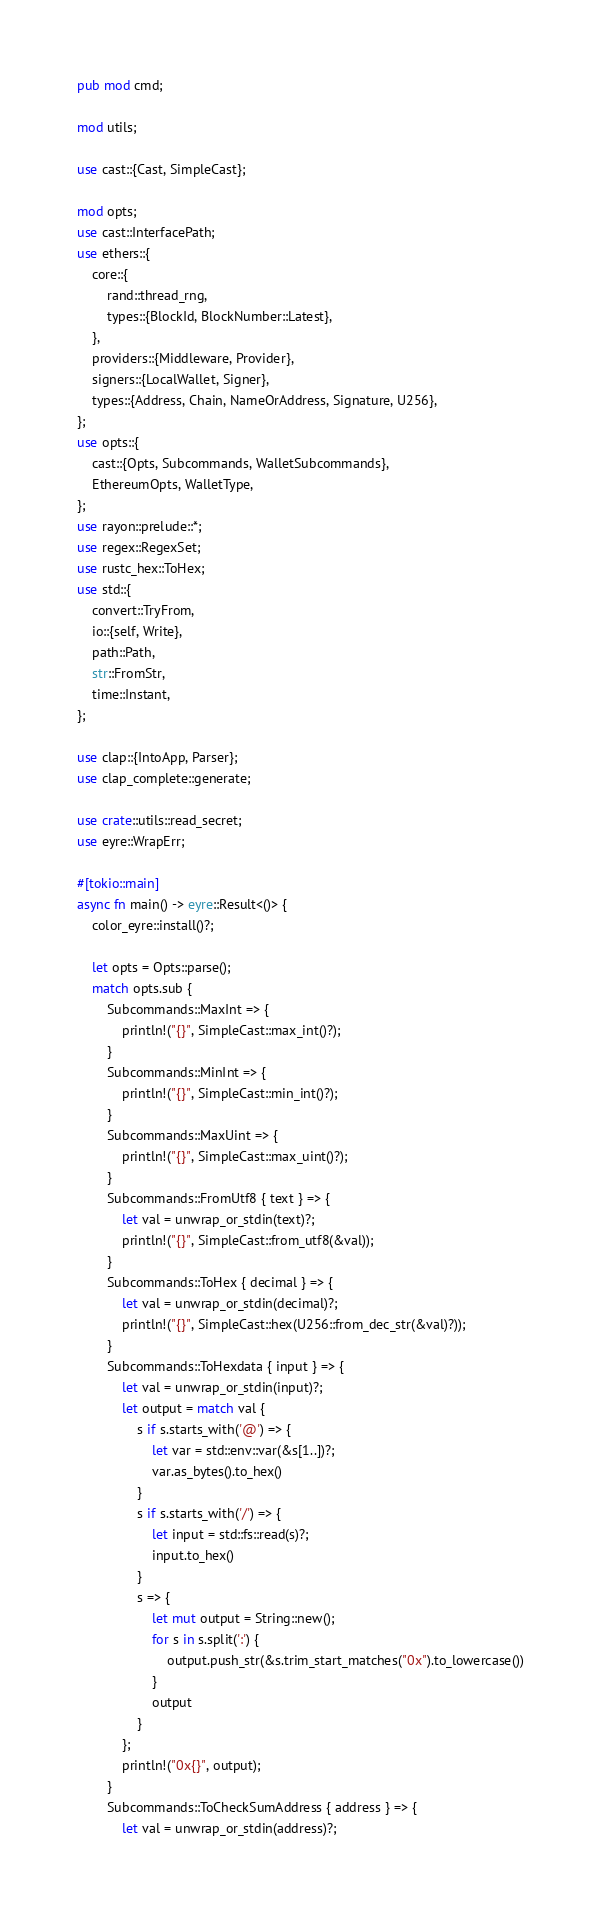<code> <loc_0><loc_0><loc_500><loc_500><_Rust_>pub mod cmd;

mod utils;

use cast::{Cast, SimpleCast};

mod opts;
use cast::InterfacePath;
use ethers::{
    core::{
        rand::thread_rng,
        types::{BlockId, BlockNumber::Latest},
    },
    providers::{Middleware, Provider},
    signers::{LocalWallet, Signer},
    types::{Address, Chain, NameOrAddress, Signature, U256},
};
use opts::{
    cast::{Opts, Subcommands, WalletSubcommands},
    EthereumOpts, WalletType,
};
use rayon::prelude::*;
use regex::RegexSet;
use rustc_hex::ToHex;
use std::{
    convert::TryFrom,
    io::{self, Write},
    path::Path,
    str::FromStr,
    time::Instant,
};

use clap::{IntoApp, Parser};
use clap_complete::generate;

use crate::utils::read_secret;
use eyre::WrapErr;

#[tokio::main]
async fn main() -> eyre::Result<()> {
    color_eyre::install()?;

    let opts = Opts::parse();
    match opts.sub {
        Subcommands::MaxInt => {
            println!("{}", SimpleCast::max_int()?);
        }
        Subcommands::MinInt => {
            println!("{}", SimpleCast::min_int()?);
        }
        Subcommands::MaxUint => {
            println!("{}", SimpleCast::max_uint()?);
        }
        Subcommands::FromUtf8 { text } => {
            let val = unwrap_or_stdin(text)?;
            println!("{}", SimpleCast::from_utf8(&val));
        }
        Subcommands::ToHex { decimal } => {
            let val = unwrap_or_stdin(decimal)?;
            println!("{}", SimpleCast::hex(U256::from_dec_str(&val)?));
        }
        Subcommands::ToHexdata { input } => {
            let val = unwrap_or_stdin(input)?;
            let output = match val {
                s if s.starts_with('@') => {
                    let var = std::env::var(&s[1..])?;
                    var.as_bytes().to_hex()
                }
                s if s.starts_with('/') => {
                    let input = std::fs::read(s)?;
                    input.to_hex()
                }
                s => {
                    let mut output = String::new();
                    for s in s.split(':') {
                        output.push_str(&s.trim_start_matches("0x").to_lowercase())
                    }
                    output
                }
            };
            println!("0x{}", output);
        }
        Subcommands::ToCheckSumAddress { address } => {
            let val = unwrap_or_stdin(address)?;</code> 